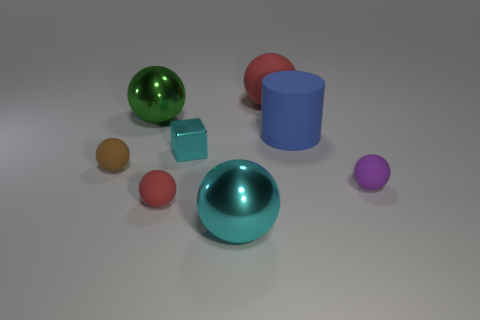Subtract all big green spheres. How many spheres are left? 5 Subtract all cylinders. How many objects are left? 7 Subtract 1 cylinders. How many cylinders are left? 0 Subtract all brown balls. How many purple cylinders are left? 0 Subtract all large balls. Subtract all cylinders. How many objects are left? 4 Add 6 blue matte objects. How many blue matte objects are left? 7 Add 2 green spheres. How many green spheres exist? 3 Add 2 tiny matte blocks. How many objects exist? 10 Subtract all cyan spheres. How many spheres are left? 5 Subtract 0 gray spheres. How many objects are left? 8 